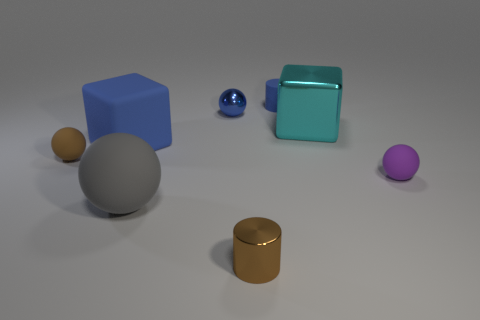Is the large object in front of the big blue matte block made of the same material as the large blue block?
Your response must be concise. Yes. What shape is the tiny object that is the same color as the shiny cylinder?
Provide a short and direct response. Sphere. There is a big block behind the rubber cube; is it the same color as the metallic object behind the big shiny cube?
Make the answer very short. No. How many tiny rubber objects are behind the purple matte sphere and in front of the brown sphere?
Provide a succinct answer. 0. What is the cyan thing made of?
Offer a very short reply. Metal. What is the shape of the purple object that is the same size as the brown ball?
Provide a succinct answer. Sphere. Are the small cylinder in front of the purple rubber thing and the tiny blue object left of the small blue rubber thing made of the same material?
Your response must be concise. Yes. What number of big metallic objects are there?
Ensure brevity in your answer.  1. How many brown things are the same shape as the blue metallic thing?
Give a very brief answer. 1. Does the small blue metal object have the same shape as the purple matte thing?
Offer a terse response. Yes. 